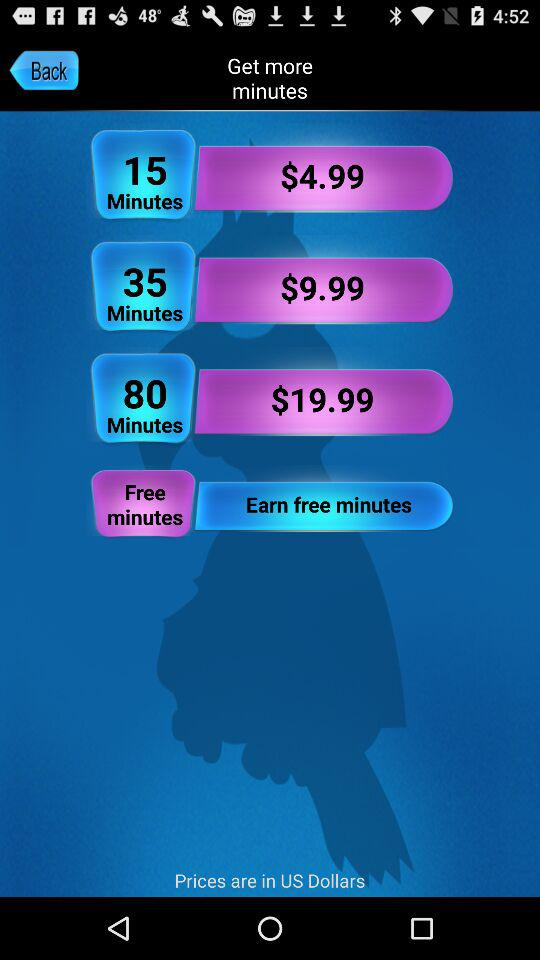What is the price of "80 Minutes"? The price of "80 Minutes" is $19.99. 